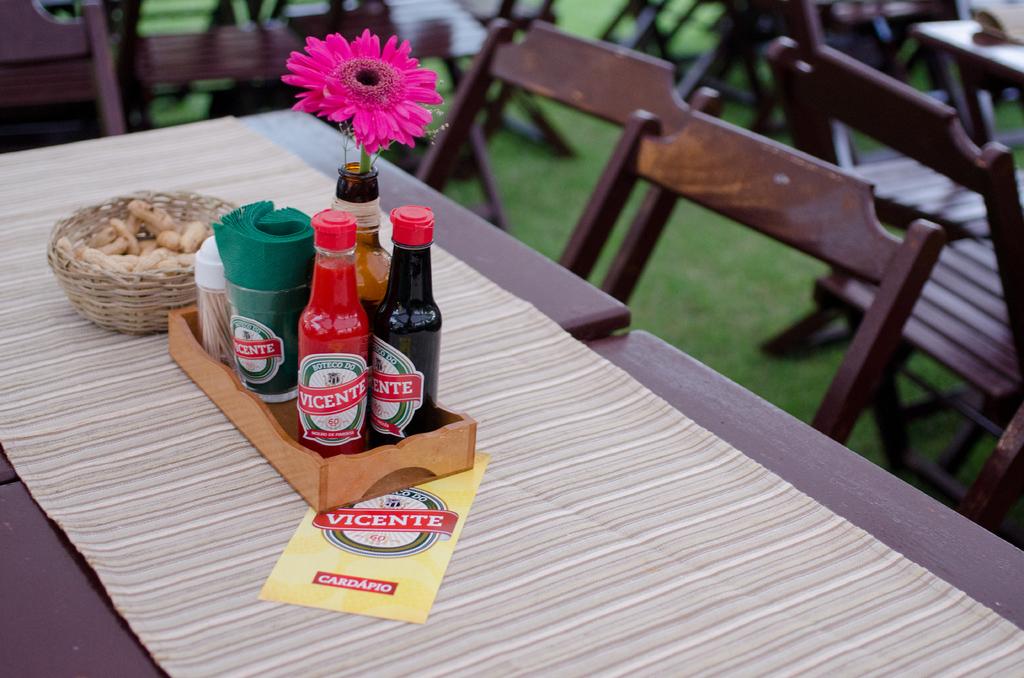What word is at the bottom of the flyer?
Offer a very short reply. Cardapio. 